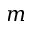<formula> <loc_0><loc_0><loc_500><loc_500>m</formula> 